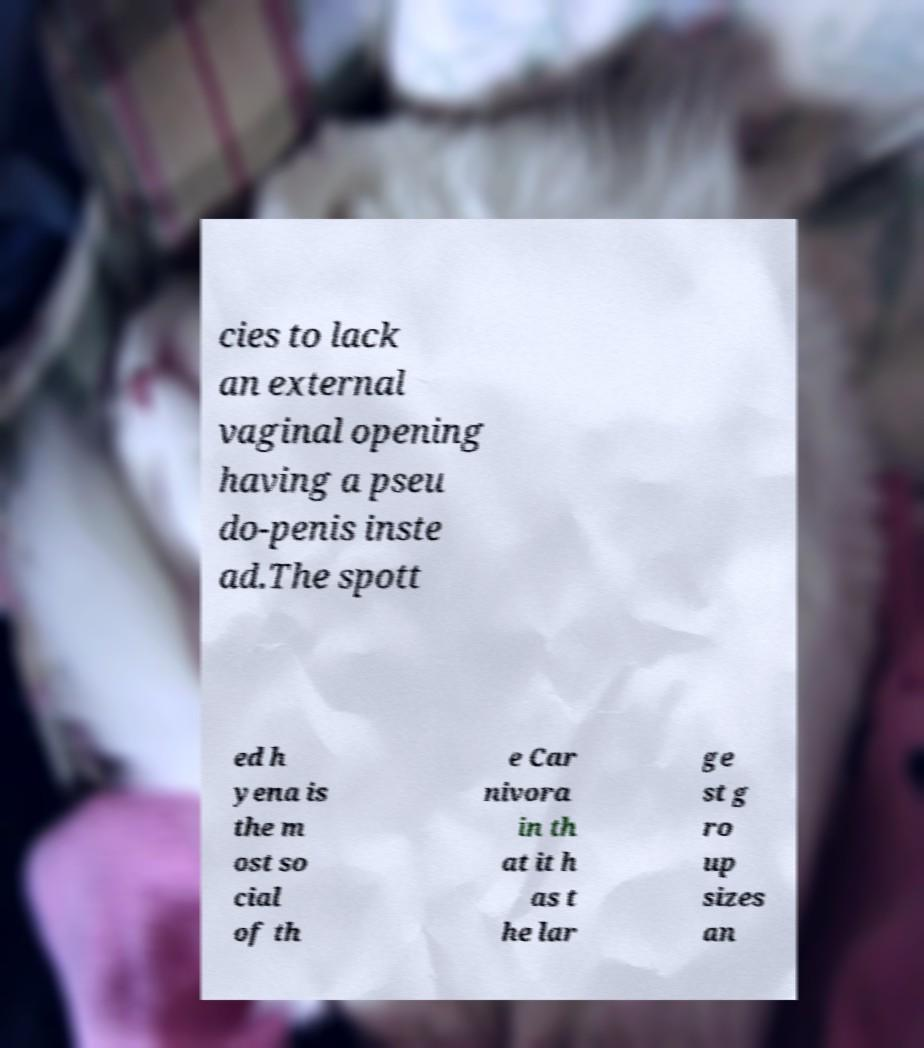I need the written content from this picture converted into text. Can you do that? cies to lack an external vaginal opening having a pseu do-penis inste ad.The spott ed h yena is the m ost so cial of th e Car nivora in th at it h as t he lar ge st g ro up sizes an 